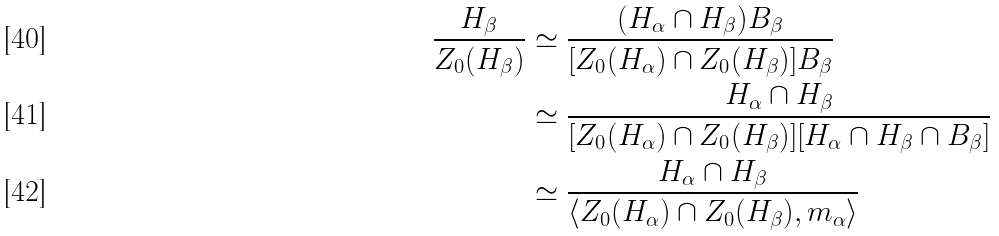Convert formula to latex. <formula><loc_0><loc_0><loc_500><loc_500>\frac { H _ { \beta } } { Z _ { 0 } ( H _ { \beta } ) } & \simeq \frac { ( H _ { \alpha } \cap H _ { \beta } ) B _ { \beta } } { [ Z _ { 0 } ( H _ { \alpha } ) \cap Z _ { 0 } ( H _ { \beta } ) ] B _ { \beta } } \\ & \simeq \frac { H _ { \alpha } \cap H _ { \beta } } { [ Z _ { 0 } ( H _ { \alpha } ) \cap Z _ { 0 } ( H _ { \beta } ) ] [ H _ { \alpha } \cap H _ { \beta } \cap B _ { \beta } ] } \\ & \simeq \frac { H _ { \alpha } \cap H _ { \beta } } { \langle Z _ { 0 } ( H _ { \alpha } ) \cap Z _ { 0 } ( H _ { \beta } ) , m _ { \alpha } \rangle }</formula> 